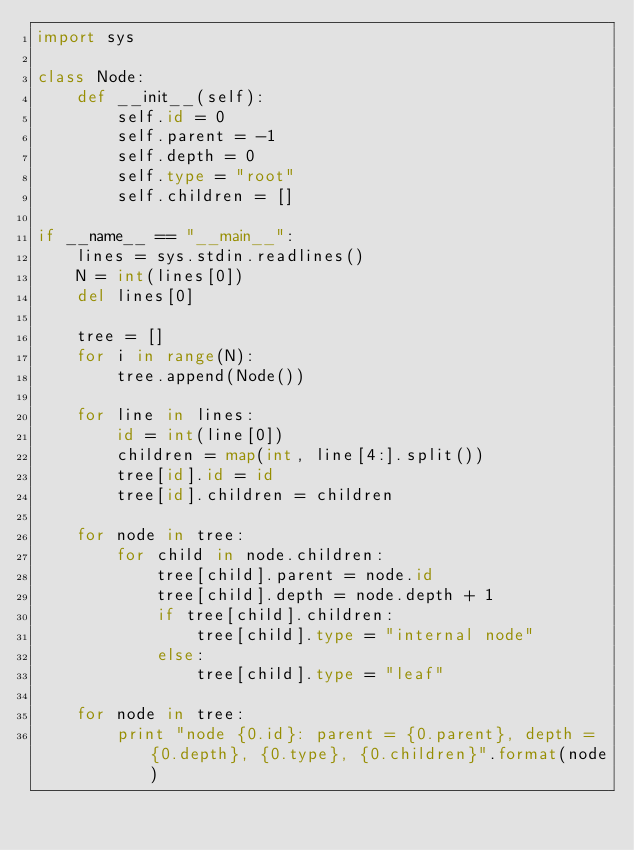<code> <loc_0><loc_0><loc_500><loc_500><_Python_>import sys

class Node:
    def __init__(self):
        self.id = 0
        self.parent = -1
        self.depth = 0
        self.type = "root"
        self.children = []

if __name__ == "__main__":
    lines = sys.stdin.readlines()
    N = int(lines[0])
    del lines[0]

    tree = []
    for i in range(N):
        tree.append(Node())

    for line in lines:
        id = int(line[0])
        children = map(int, line[4:].split())
        tree[id].id = id
        tree[id].children = children

    for node in tree:
        for child in node.children:
            tree[child].parent = node.id
            tree[child].depth = node.depth + 1
            if tree[child].children:
                tree[child].type = "internal node"
            else:
                tree[child].type = "leaf"

    for node in tree:
        print "node {0.id}: parent = {0.parent}, depth = {0.depth}, {0.type}, {0.children}".format(node)</code> 